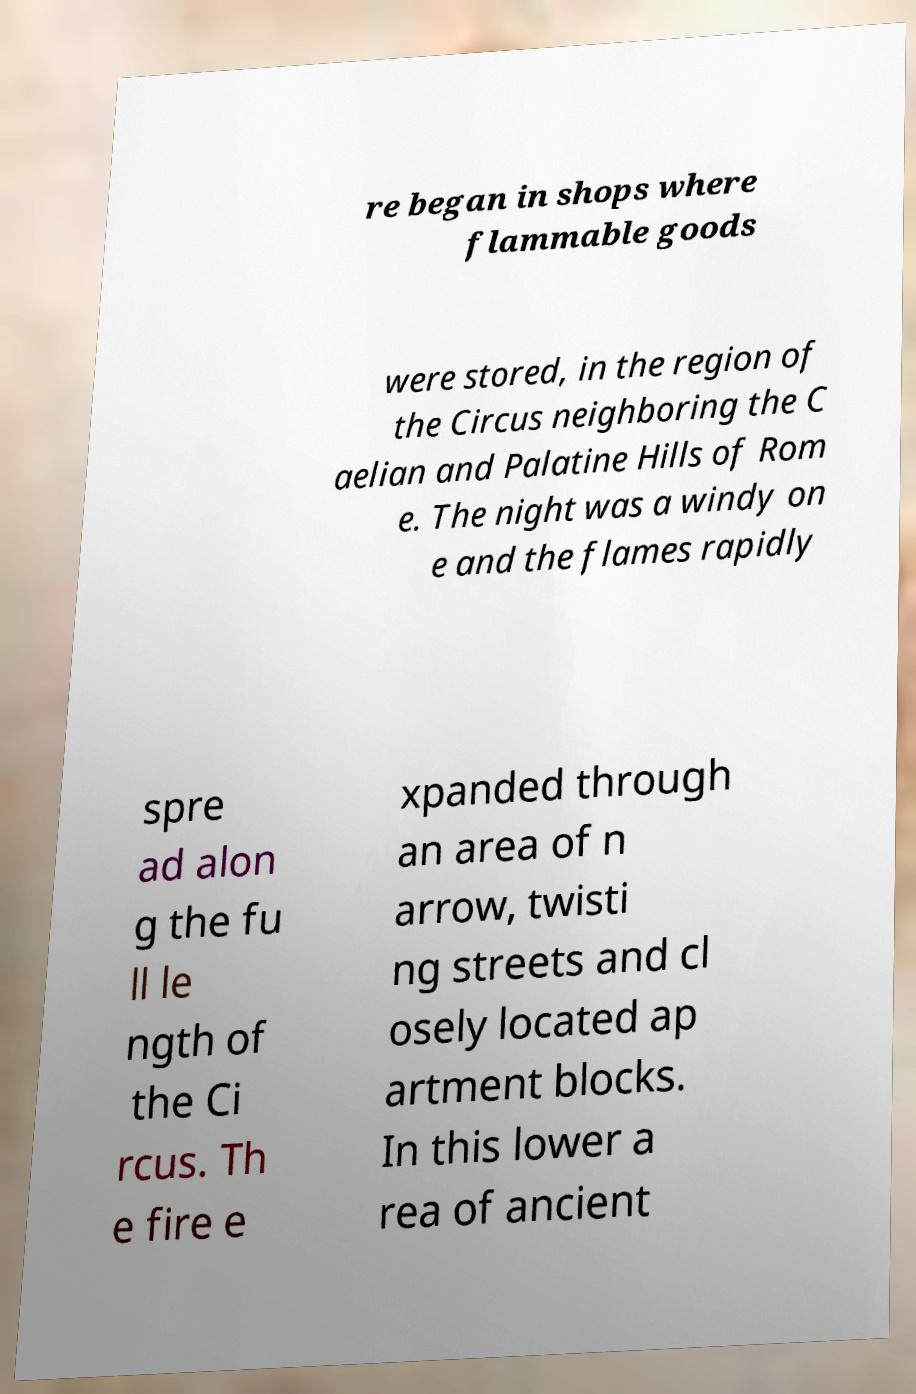Could you extract and type out the text from this image? re began in shops where flammable goods were stored, in the region of the Circus neighboring the C aelian and Palatine Hills of Rom e. The night was a windy on e and the flames rapidly spre ad alon g the fu ll le ngth of the Ci rcus. Th e fire e xpanded through an area of n arrow, twisti ng streets and cl osely located ap artment blocks. In this lower a rea of ancient 